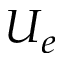<formula> <loc_0><loc_0><loc_500><loc_500>U _ { e }</formula> 